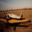The given image can contain different types of transport vehicles. People use these vehicles to travel around in their day-to-day lives. It could be air travel or a slower means of transport on the ground. Please identify the type of transport option in the picture. The aircraft depicted in the image is a commercial jet airliner, specifically designed for carrying large numbers of passengers or significant cargo loads across long distances. Utilizing powerful jet engines, this type of airliner is extremely effective for both international and domestic routes, offering a superior speed compared to land-based transportation methods like cars or trains. The fuselage design and wing structure also suggest modern aerodynamic efficiencies, further enhancing its performance for global travel, making it an indispensable tool in connecting economies and cultures around the world. 